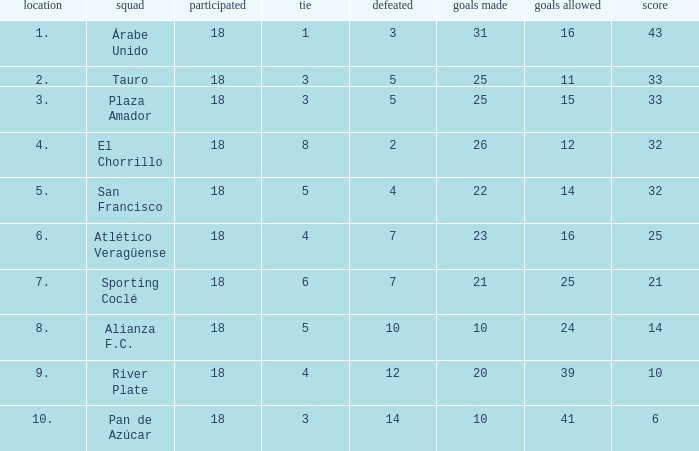How many goals were conceded by teams with 32 points, more than 2 losses and more than 22 goals scored? 0.0. 